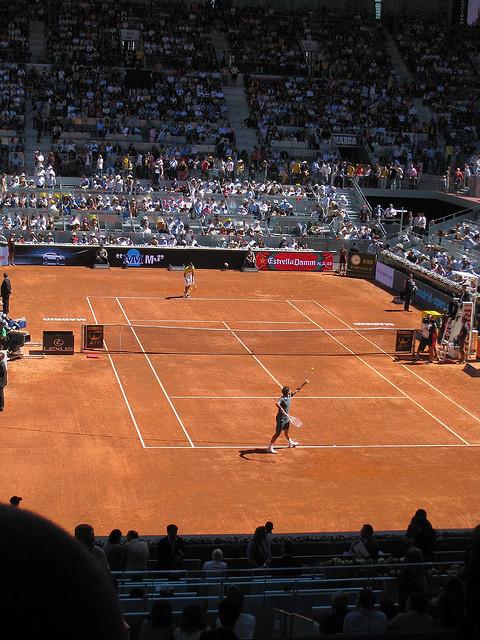Are they playing baseball?
Keep it brief. No. Is this a professional game?
Quick response, please. Yes. Is the stadium full?
Be succinct. Yes. What color is the ground?
Answer briefly. Brown. Which color is the tennis court?
Short answer required. Brown. What are the men playing?
Concise answer only. Tennis. What is the man's profession?
Quick response, please. Tennis player. What is the name of this event?
Keep it brief. Tennis. What field is this?
Concise answer only. Tennis. Is this a clay court?
Write a very short answer. Yes. What advertisement is on the net?
Give a very brief answer. Lexus. What game is being played?
Give a very brief answer. Tennis. 